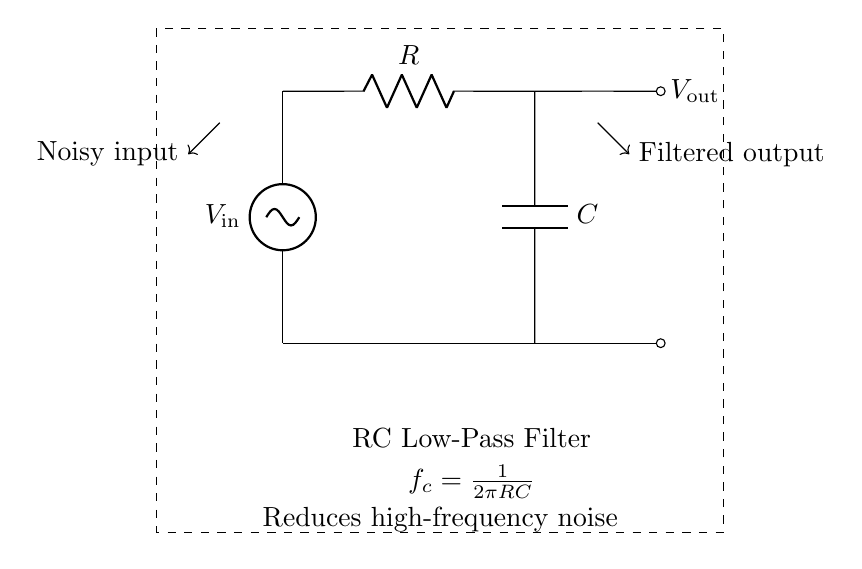What is the component at the input of the circuit? The input of the circuit is connected to a voltage source labeled V_in.
Answer: voltage source What does the capacitor do in this circuit? The capacitor works in conjunction with the resistor to filter out high-frequency noise from the input signal.
Answer: filter noise What is the cutoff frequency formula for this RC filter? The cutoff frequency is given by the formula \( f_c = \frac{1}{2\pi RC} \) which is indicated in the diagram.
Answer: \( \frac{1}{2\pi RC} \) What establishes the low-pass characteristic of this filter? The resistor and capacitor work together to create a low-pass filter characteristic by allowing low frequencies to pass while attenuating high frequencies.
Answer: resistor and capacitor Which voltage is filtered out in this circuit? The circuit is designed to filter out high-frequency voltage components from the noisy input, resulting in a smoother output voltage.
Answer: high-frequency voltage 